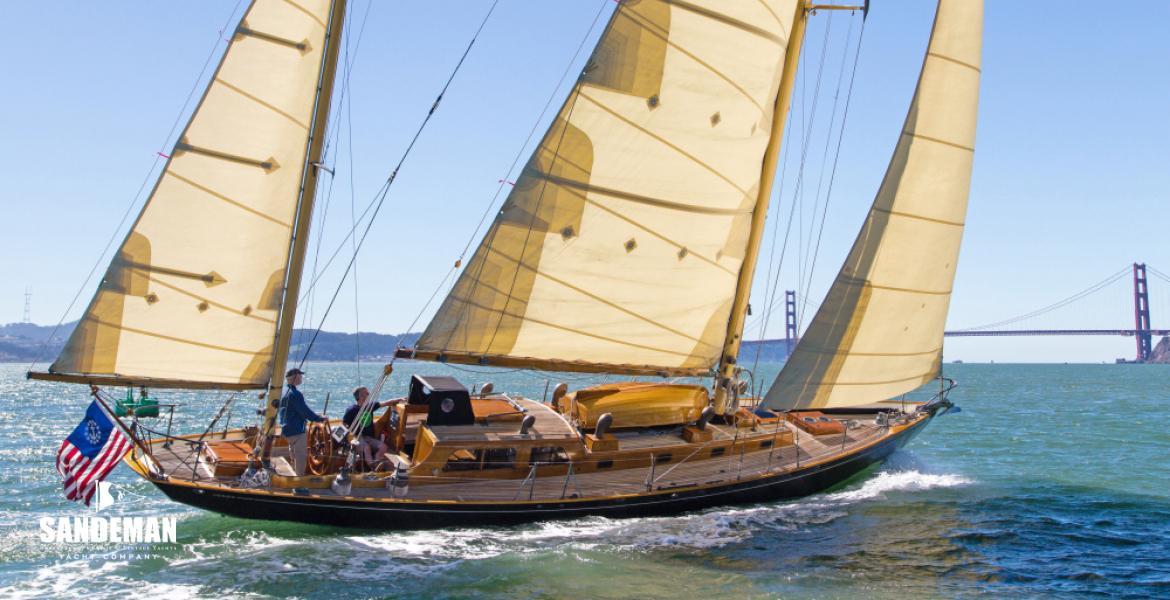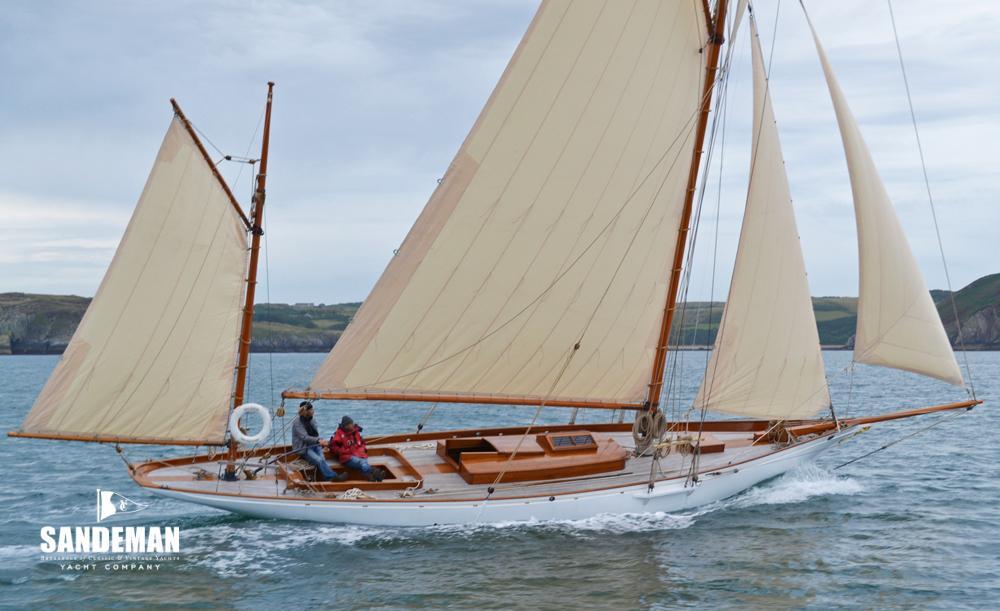The first image is the image on the left, the second image is the image on the right. Examine the images to the left and right. Is the description "Two sailboats on open water are headed in the same direction, but only one has a flag flying from the stern." accurate? Answer yes or no. Yes. The first image is the image on the left, the second image is the image on the right. Evaluate the accuracy of this statement regarding the images: "In at least one image there is a sail boat with four open sails.". Is it true? Answer yes or no. Yes. 